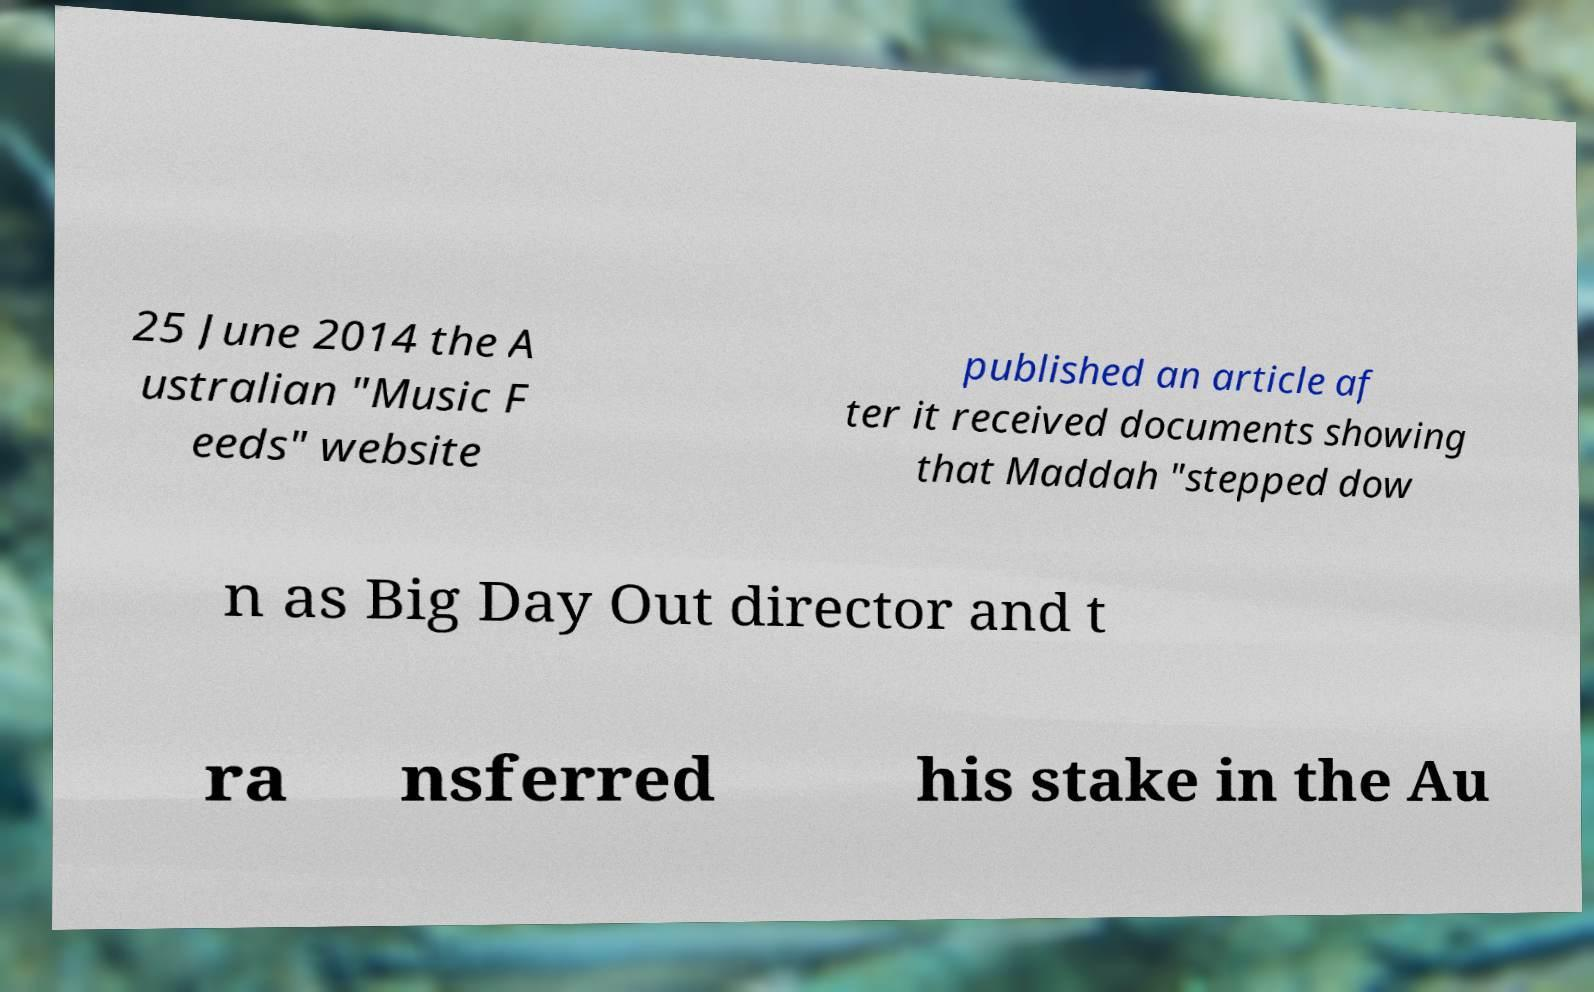Could you extract and type out the text from this image? 25 June 2014 the A ustralian "Music F eeds" website published an article af ter it received documents showing that Maddah "stepped dow n as Big Day Out director and t ra nsferred his stake in the Au 